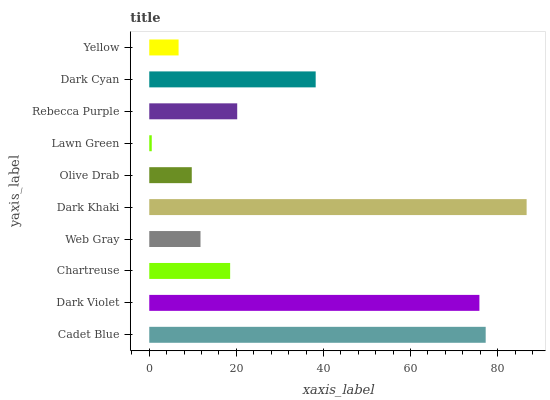Is Lawn Green the minimum?
Answer yes or no. Yes. Is Dark Khaki the maximum?
Answer yes or no. Yes. Is Dark Violet the minimum?
Answer yes or no. No. Is Dark Violet the maximum?
Answer yes or no. No. Is Cadet Blue greater than Dark Violet?
Answer yes or no. Yes. Is Dark Violet less than Cadet Blue?
Answer yes or no. Yes. Is Dark Violet greater than Cadet Blue?
Answer yes or no. No. Is Cadet Blue less than Dark Violet?
Answer yes or no. No. Is Rebecca Purple the high median?
Answer yes or no. Yes. Is Chartreuse the low median?
Answer yes or no. Yes. Is Dark Khaki the high median?
Answer yes or no. No. Is Dark Cyan the low median?
Answer yes or no. No. 